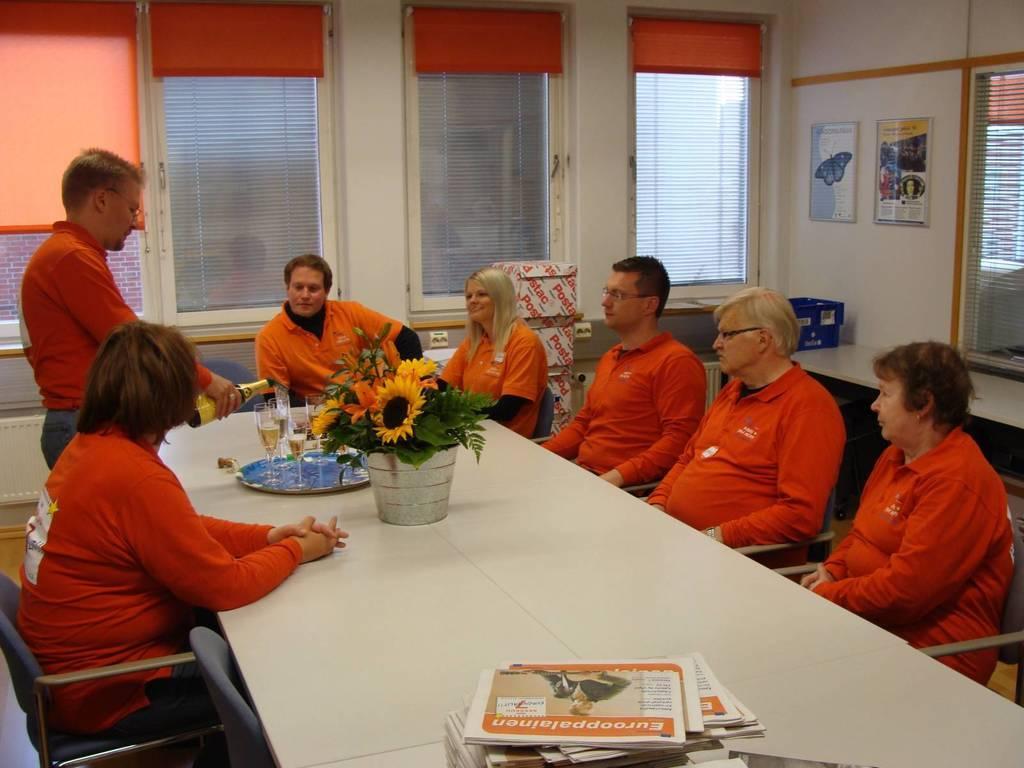Can you describe this image briefly? There are group of people sitting on the chairs and one person is standing. This is a table with a flower vase,Books,plate and wine glasses placed on it. This is a cardboard box. These are the posters attached to the wall. These are the windows which are closed. This man is holding a wine bottle and serving wine. 